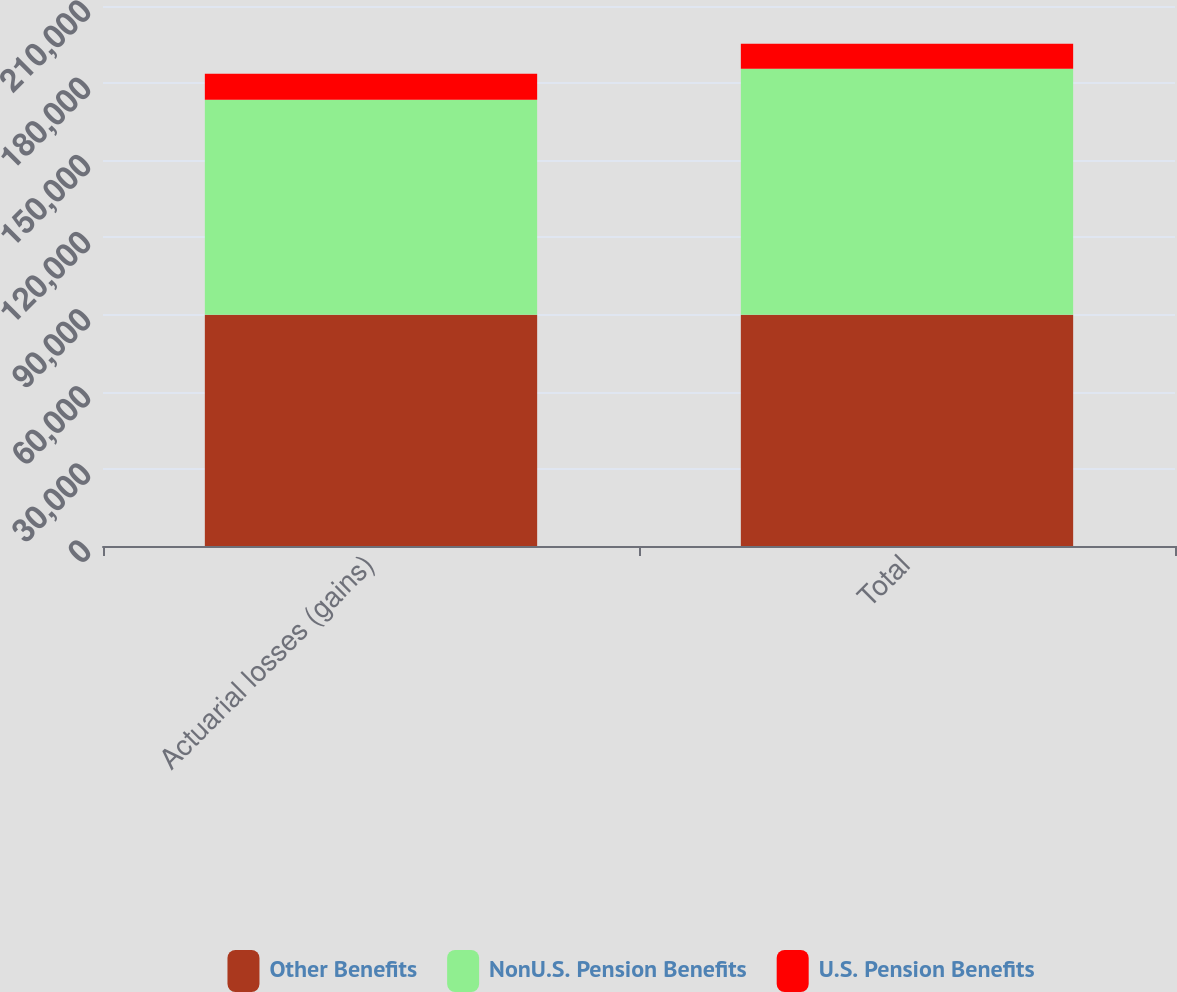<chart> <loc_0><loc_0><loc_500><loc_500><stacked_bar_chart><ecel><fcel>Actuarial losses (gains)<fcel>Total<nl><fcel>Other Benefits<fcel>89956<fcel>89956<nl><fcel>NonU.S. Pension Benefits<fcel>83560<fcel>95686<nl><fcel>U.S. Pension Benefits<fcel>10092<fcel>9635<nl></chart> 